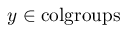<formula> <loc_0><loc_0><loc_500><loc_500>y \in { c o l g r o u p s }</formula> 